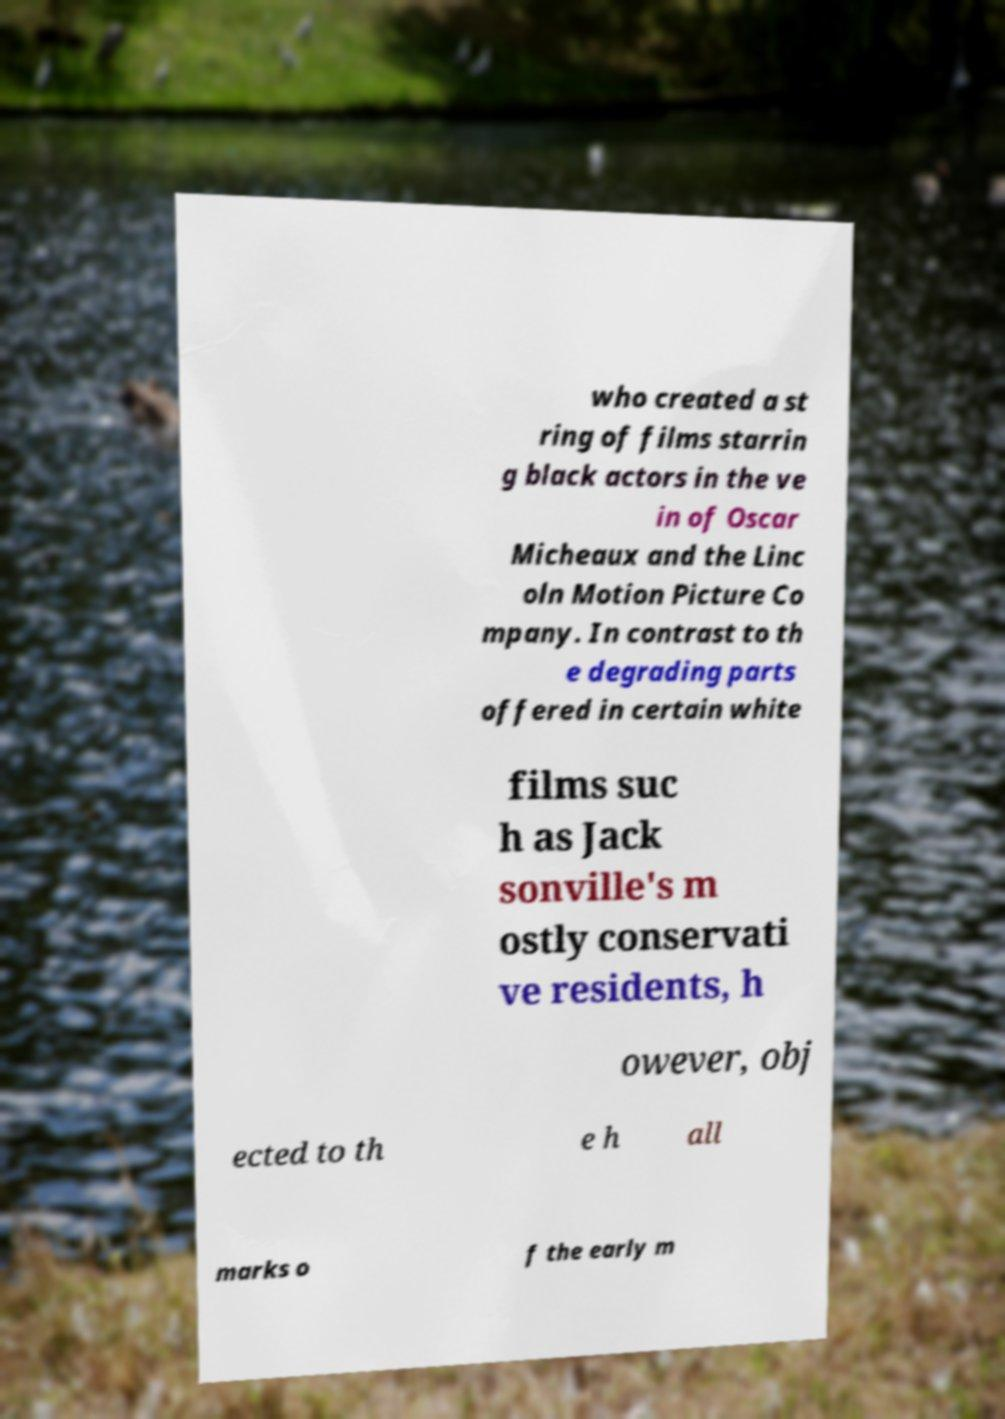For documentation purposes, I need the text within this image transcribed. Could you provide that? who created a st ring of films starrin g black actors in the ve in of Oscar Micheaux and the Linc oln Motion Picture Co mpany. In contrast to th e degrading parts offered in certain white films suc h as Jack sonville's m ostly conservati ve residents, h owever, obj ected to th e h all marks o f the early m 